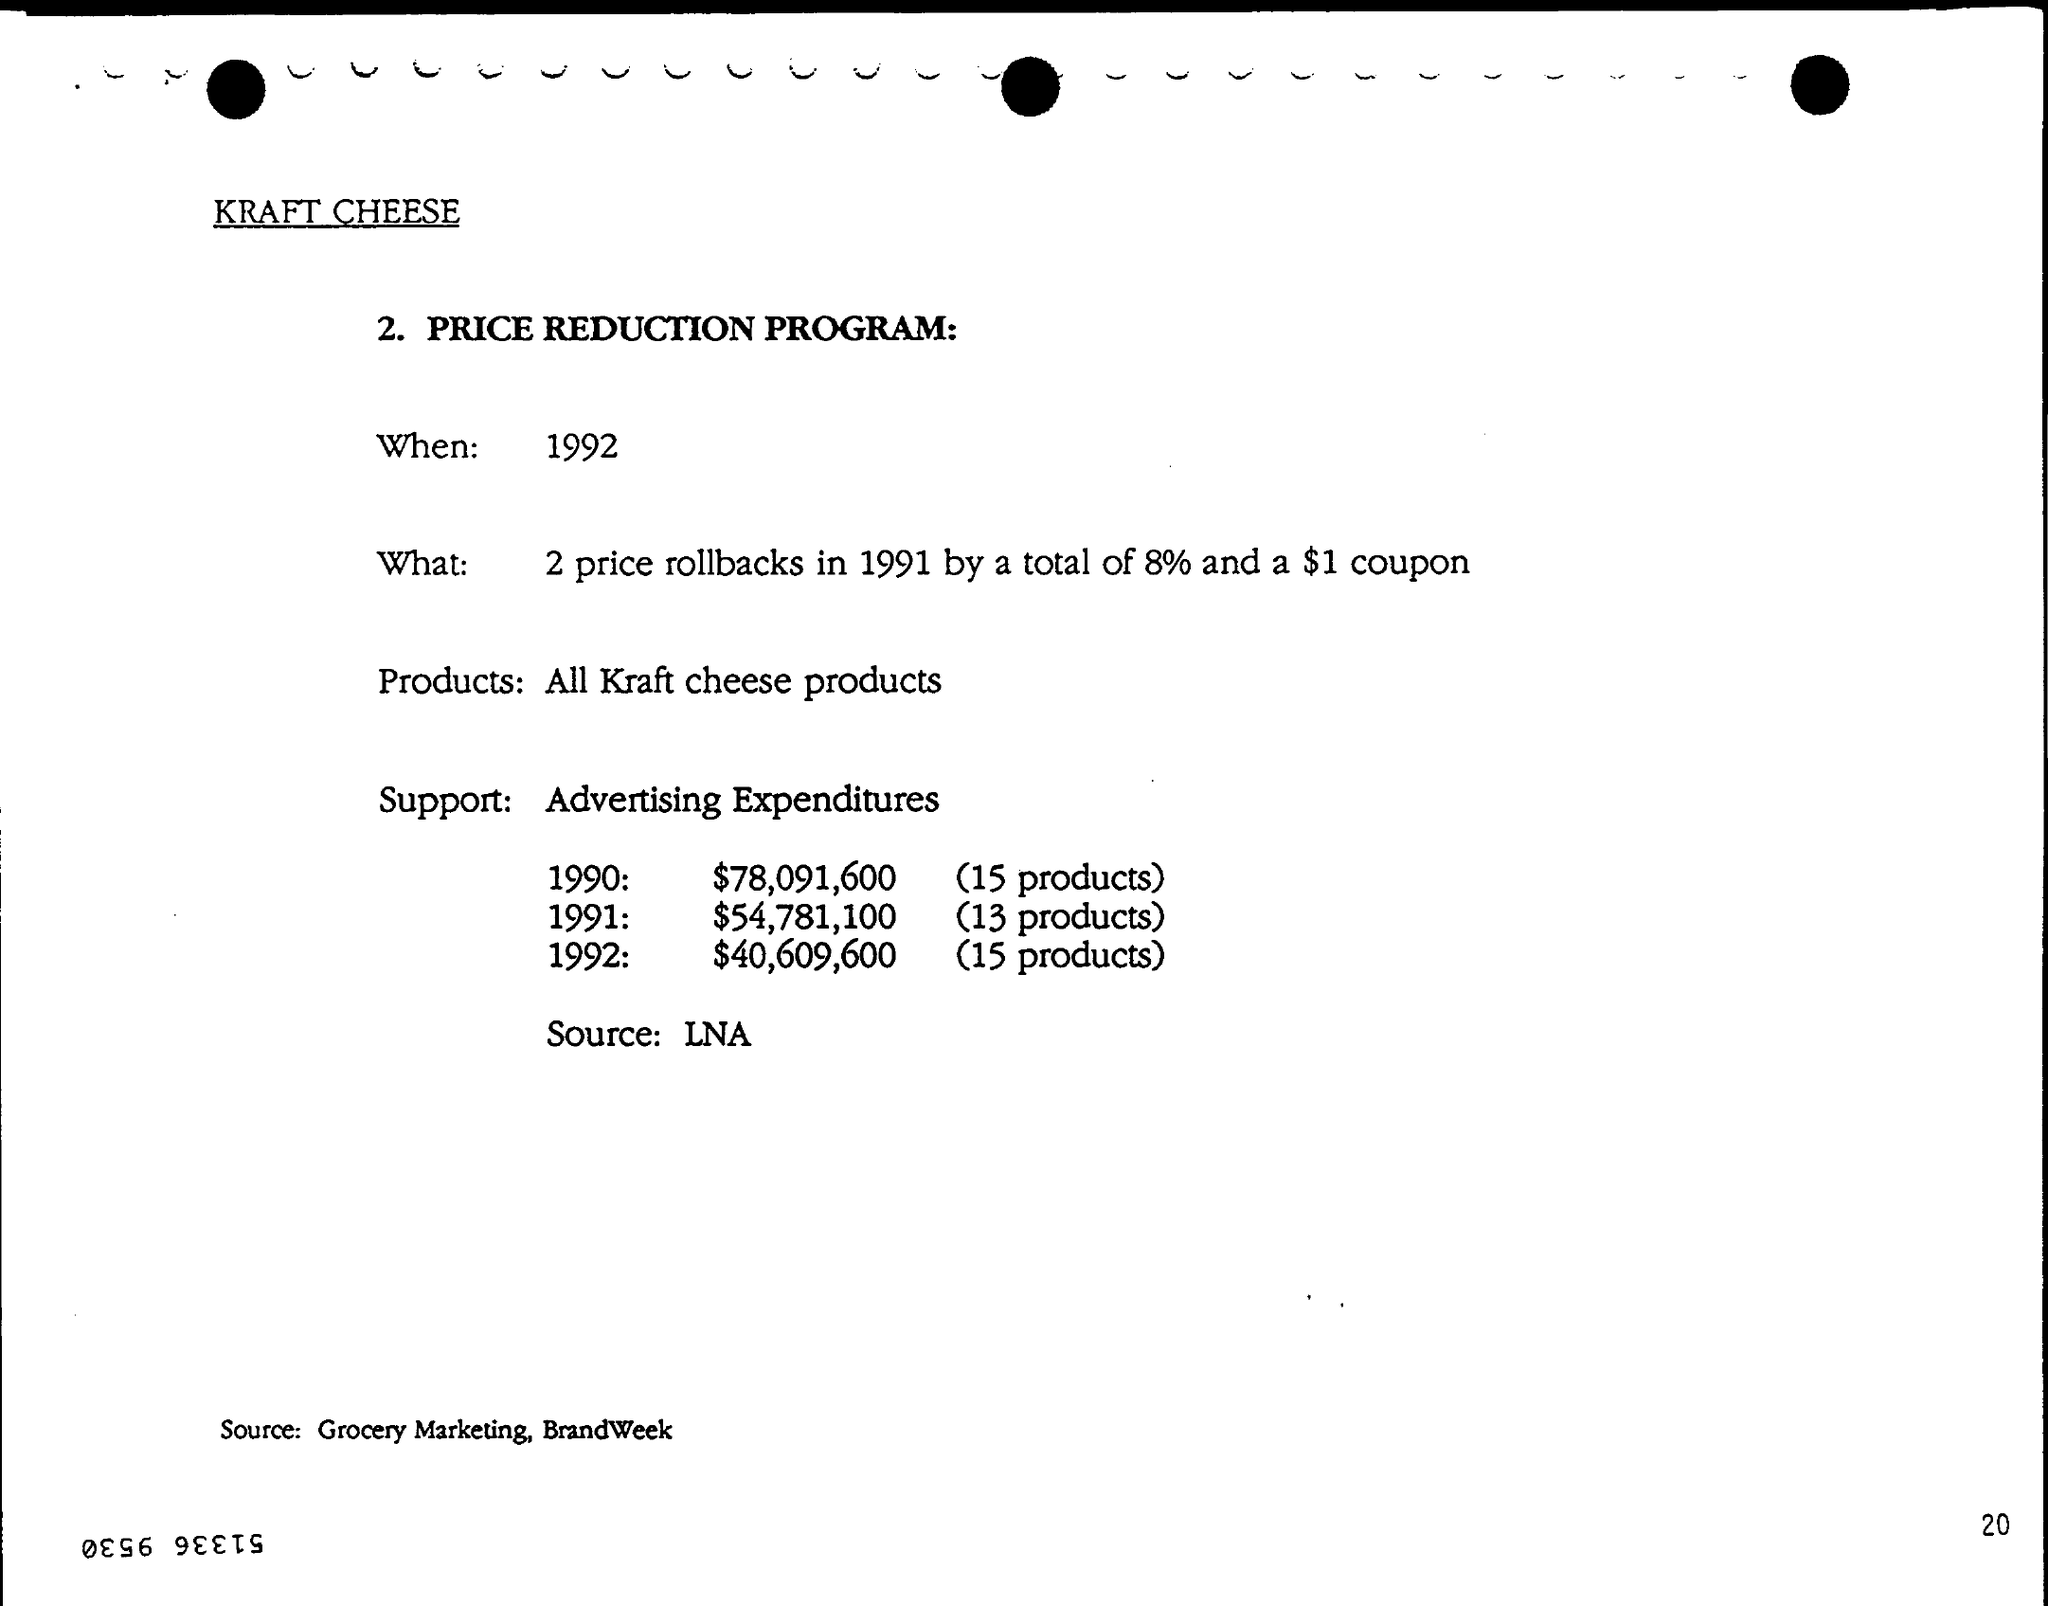When is the PRICE REDUCTION PROGRAM?
Offer a terse response. 1992. Which products are under the price reduction program?
Offer a very short reply. All Kraft cheese products. What is the source mentioned at the bottom of the page?
Ensure brevity in your answer.  Grocery Marketing, BrandWeek. 